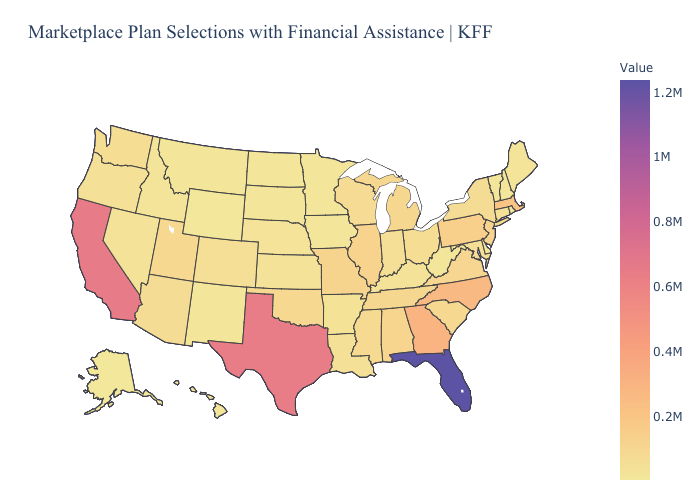Among the states that border Kansas , which have the highest value?
Short answer required. Missouri. Which states hav the highest value in the Northeast?
Give a very brief answer. Massachusetts. Among the states that border New Mexico , does Colorado have the lowest value?
Keep it brief. Yes. Which states have the lowest value in the USA?
Give a very brief answer. Alaska. Does Florida have the highest value in the USA?
Give a very brief answer. Yes. 